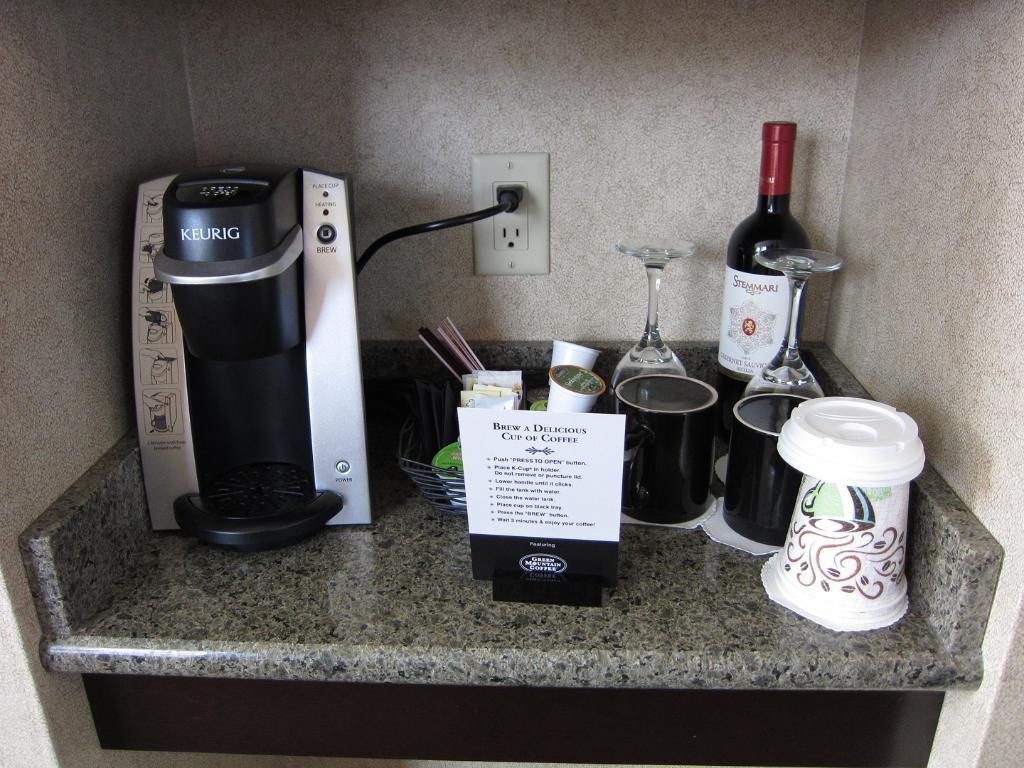<image>
Share a concise interpretation of the image provided. A hotel counter with a Keurig machine and a bottle of Stemmari wine. 